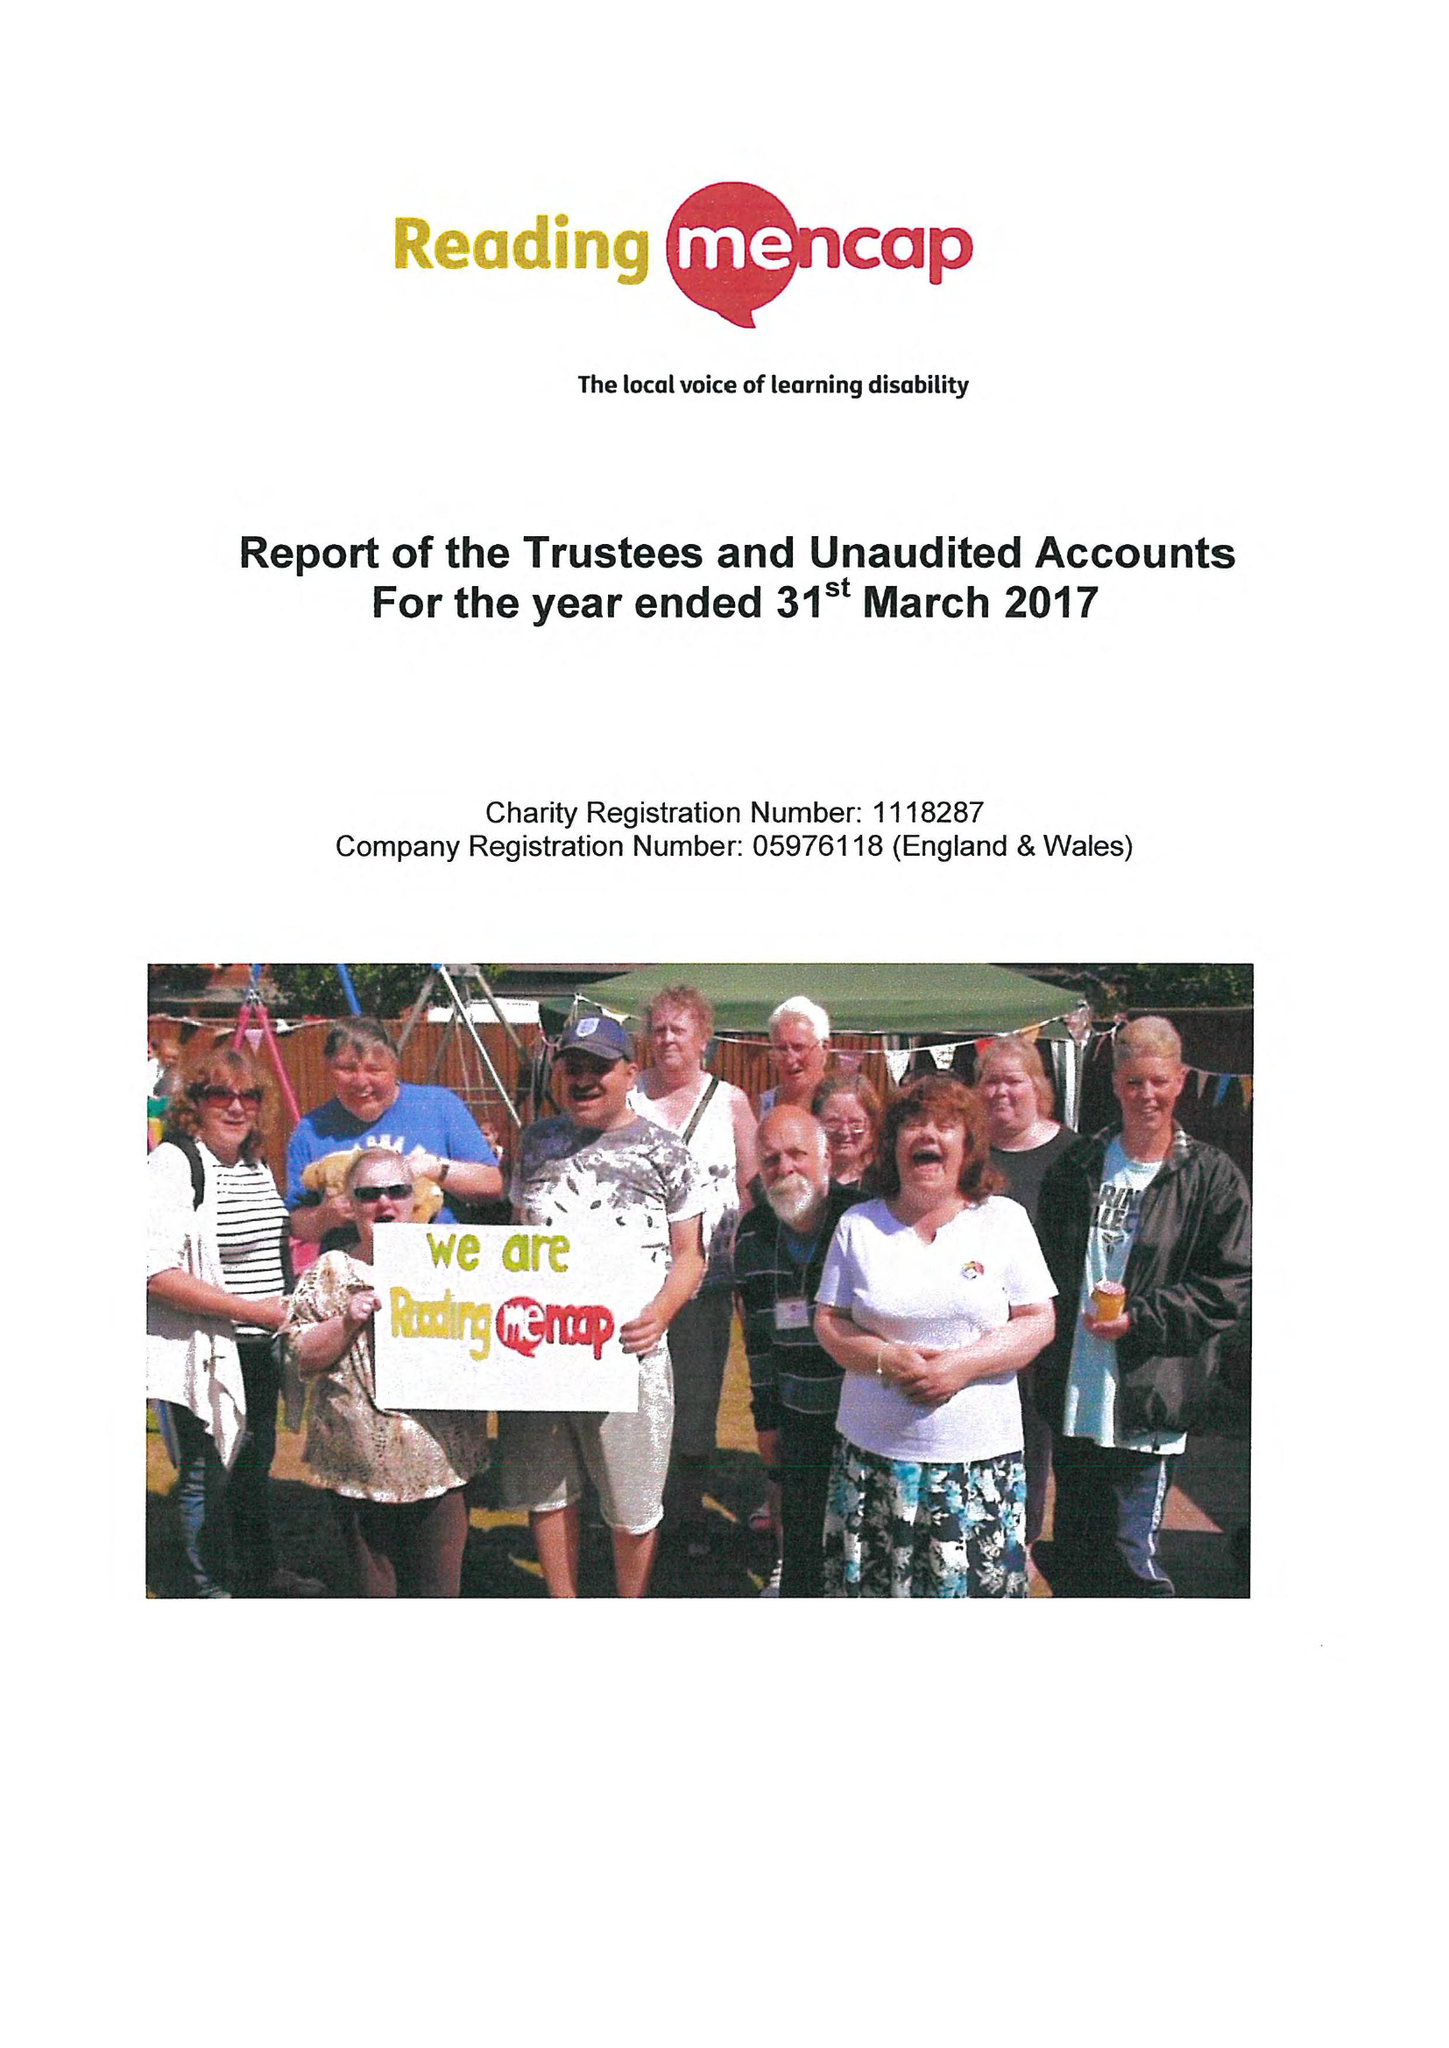What is the value for the spending_annually_in_british_pounds?
Answer the question using a single word or phrase. 362511.00 